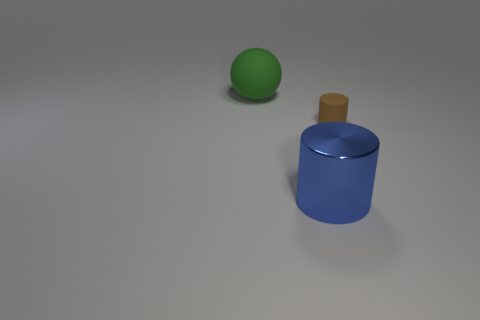Is the number of brown things that are to the left of the big metallic cylinder the same as the number of matte things in front of the green rubber sphere?
Make the answer very short. No. There is a large thing that is the same shape as the small brown rubber object; what is its color?
Offer a very short reply. Blue. Are there any other things that are the same shape as the green rubber thing?
Make the answer very short. No. What is the size of the brown rubber object that is the same shape as the large metal object?
Keep it short and to the point. Small. What number of big green spheres are the same material as the small thing?
Offer a terse response. 1. There is a cylinder that is in front of the cylinder that is on the right side of the metallic object; is there a green ball to the left of it?
Make the answer very short. Yes. What is the shape of the blue metallic object?
Ensure brevity in your answer.  Cylinder. Is the material of the large thing that is behind the metal thing the same as the large thing right of the large green rubber object?
Make the answer very short. No. How many other big matte objects have the same color as the large rubber object?
Your response must be concise. 0. The object that is both behind the large metal thing and on the left side of the small brown thing has what shape?
Provide a short and direct response. Sphere. 